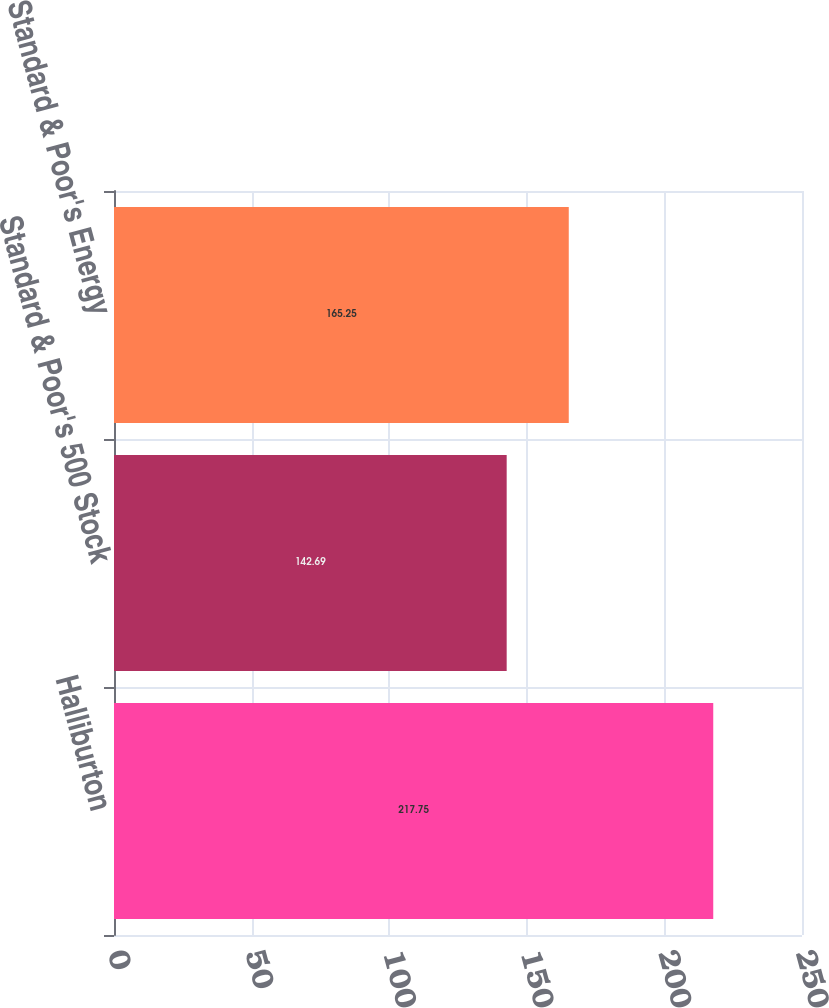Convert chart. <chart><loc_0><loc_0><loc_500><loc_500><bar_chart><fcel>Halliburton<fcel>Standard & Poor's 500 Stock<fcel>Standard & Poor's Energy<nl><fcel>217.75<fcel>142.69<fcel>165.25<nl></chart> 